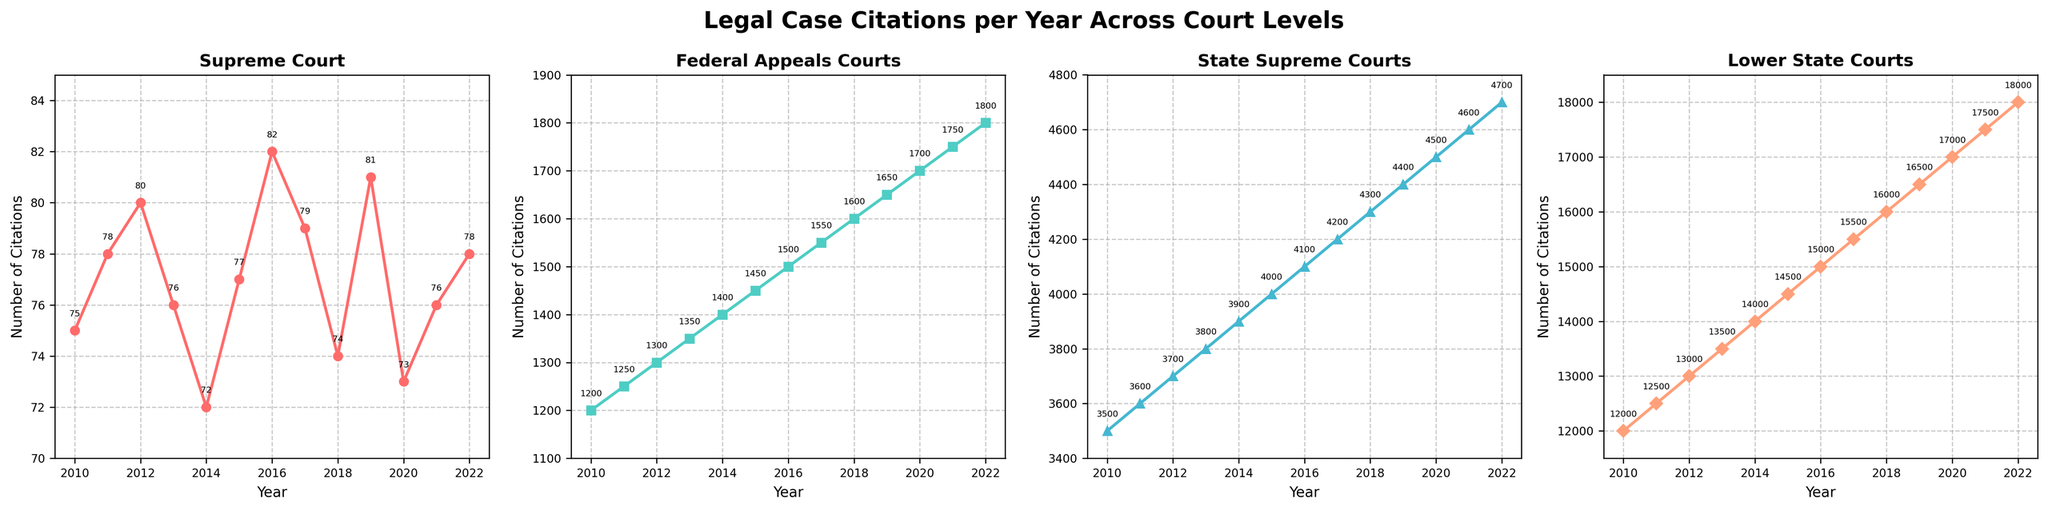Which court level has the most citations in 2022? By looking at the numbers at the top of the lines for each subplot in 2022, Lower State Courts have the highest number of citations.
Answer: Lower State Courts What is the difference in citations between the Supreme Court and State Supreme Courts in 2015? The Supreme Court has 77 citations, and State Supreme Courts have 4000 citations in 2015. The difference is 4000 - 77 = 3923.
Answer: 3923 How have citations for Federal Appeals Courts changed from 2010 to 2022? In 2010, Federal Appeals Courts had 1200 citations, and in 2022 they have 1800 citations. The change is 1800 - 1200, which is an increase of 600 citations.
Answer: Increased by 600 Which year shows the highest number of citations for State Supreme Courts? By examining the peaks in the trend line for State Supreme Courts, the year 2022 shows 4700 citations, which is the highest.
Answer: 2022 On average, how many citations per year did the Lower State Courts receive from 2010 to 2022? Adding citations from 2010 to 2022 (12000+12500+13000+13500+14000+14500+15000+15500+16000+16500+17000+17500+18000) totals 186000. Dividing by 13 years gives an average of 186000 / 13 = 14307.69 ≈ 14308 citations per year.
Answer: 14308 Compare the trend of citations between Supreme Court and Federal Appeals Courts from 2010 to 2022. Supreme Court citations fluctuate slightly, but do not show a consistent trend over the years. Federal Appeals Courts show a steady increase in citations every year.
Answer: Supreme Court: fluctuates; Federal Appeals Courts: steadily increases Are there any years where citations are higher for Supreme Court than Federal Appeals Courts? By comparing the values each year, there is no year where Supreme Court citations (ranging from 72 to 82) are higher than Federal Appeals Courts (ranging from 1200 to 1800).
Answer: No What is the average number of citations for the State Supreme Courts and Lower State Courts in 2015? State Supreme Courts in 2015 have 4000 citations, and Lower State Courts have 14500. The average is (4000 + 14500) / 2 = 9250.
Answer: 9250 Which court shows the most significant increase in citations from 2010 to 2022? Lower State Courts go from 12000 to 18000, an increase of 6000 citations. The percent increase for Lower State Courts is 6000 / 12000 * 100 = 50%. Other courts have lower absolute increases and percentages. Lower State Courts show the most significant increase.
Answer: Lower State Courts 